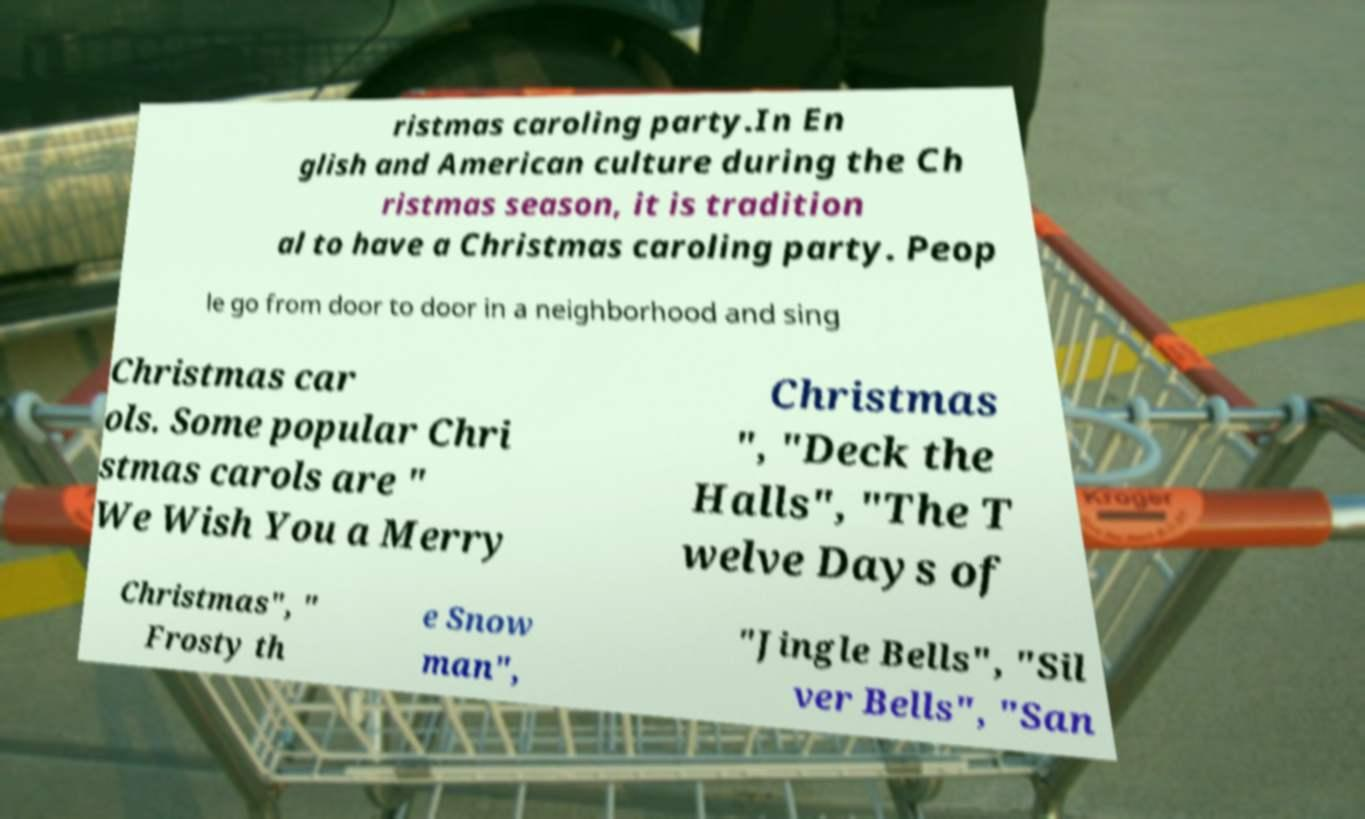There's text embedded in this image that I need extracted. Can you transcribe it verbatim? ristmas caroling party.In En glish and American culture during the Ch ristmas season, it is tradition al to have a Christmas caroling party. Peop le go from door to door in a neighborhood and sing Christmas car ols. Some popular Chri stmas carols are " We Wish You a Merry Christmas ", "Deck the Halls", "The T welve Days of Christmas", " Frosty th e Snow man", "Jingle Bells", "Sil ver Bells", "San 